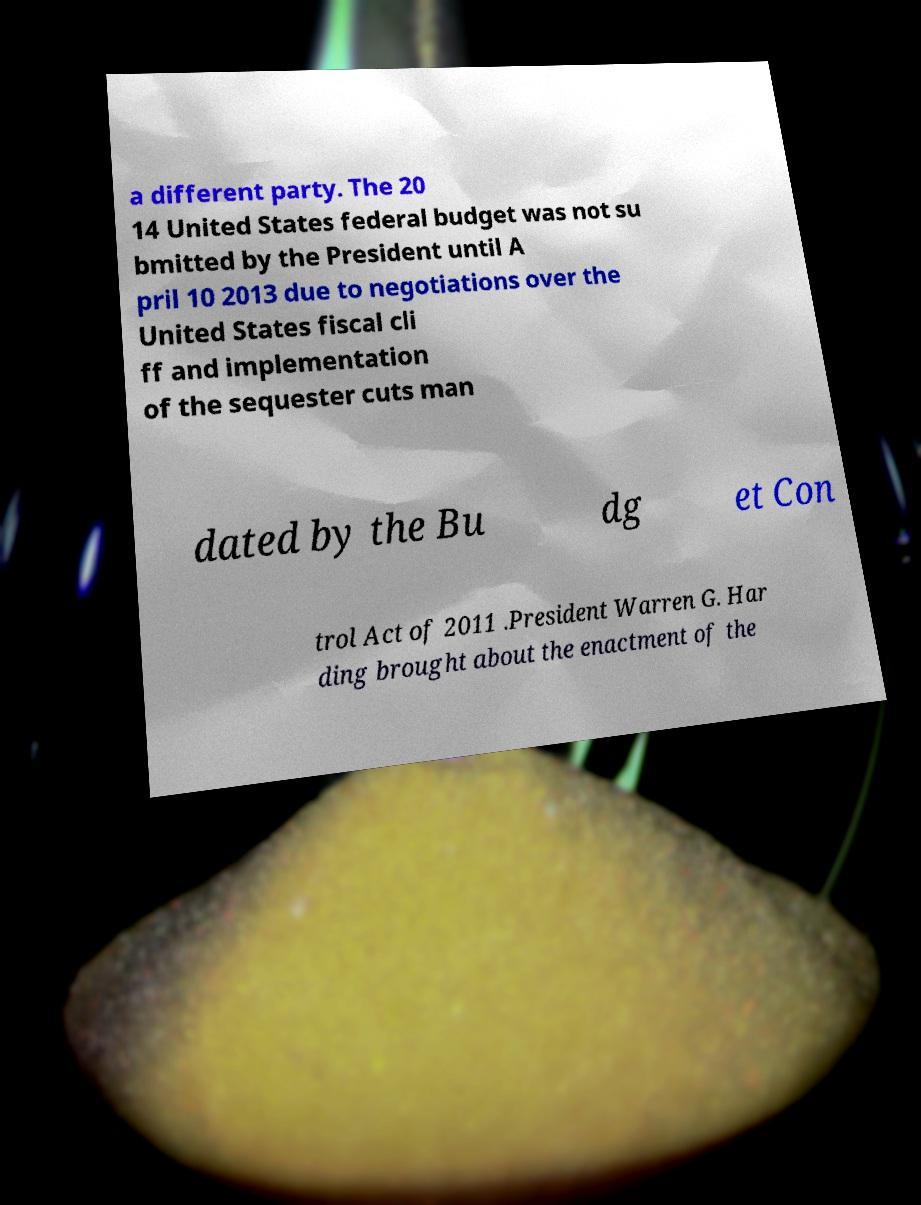Could you assist in decoding the text presented in this image and type it out clearly? a different party. The 20 14 United States federal budget was not su bmitted by the President until A pril 10 2013 due to negotiations over the United States fiscal cli ff and implementation of the sequester cuts man dated by the Bu dg et Con trol Act of 2011 .President Warren G. Har ding brought about the enactment of the 